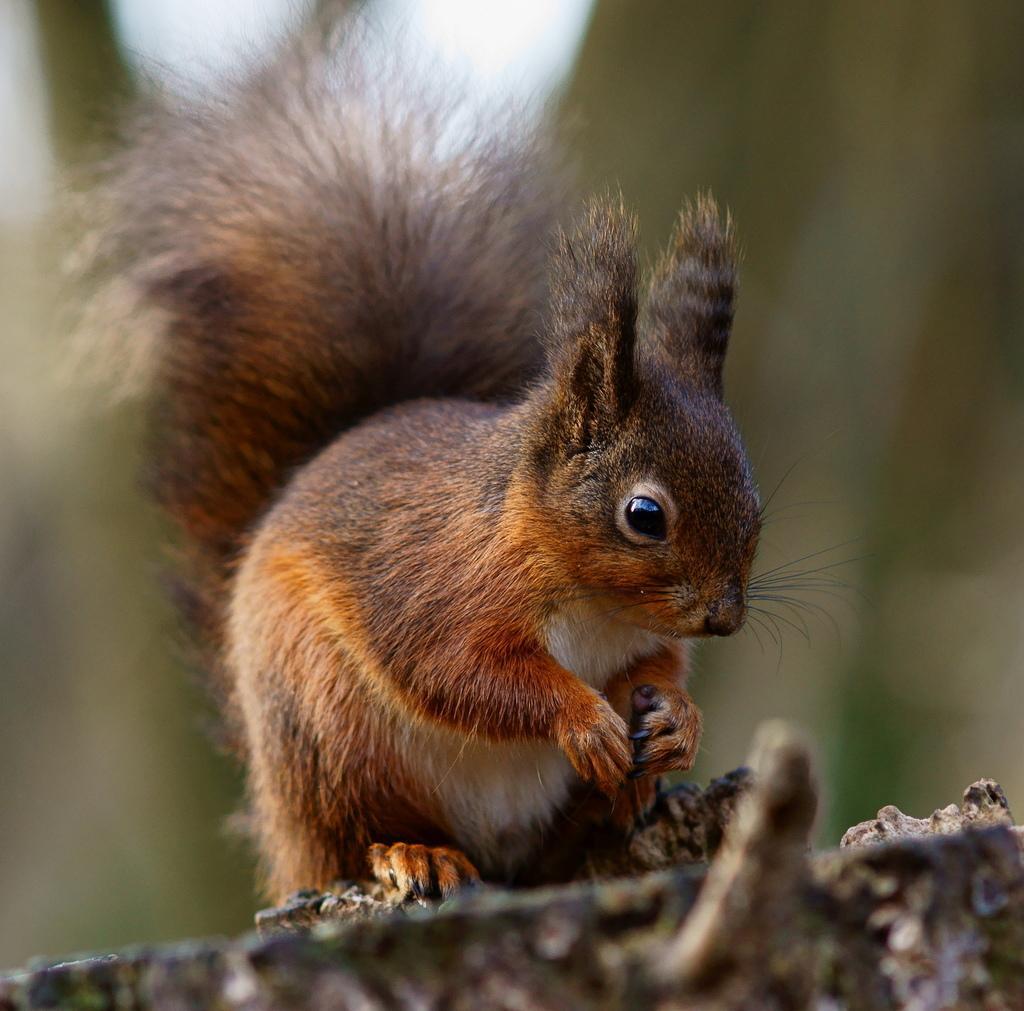Could you give a brief overview of what you see in this image? In this image we can see a squirrel on the surface and the background is blurred. 